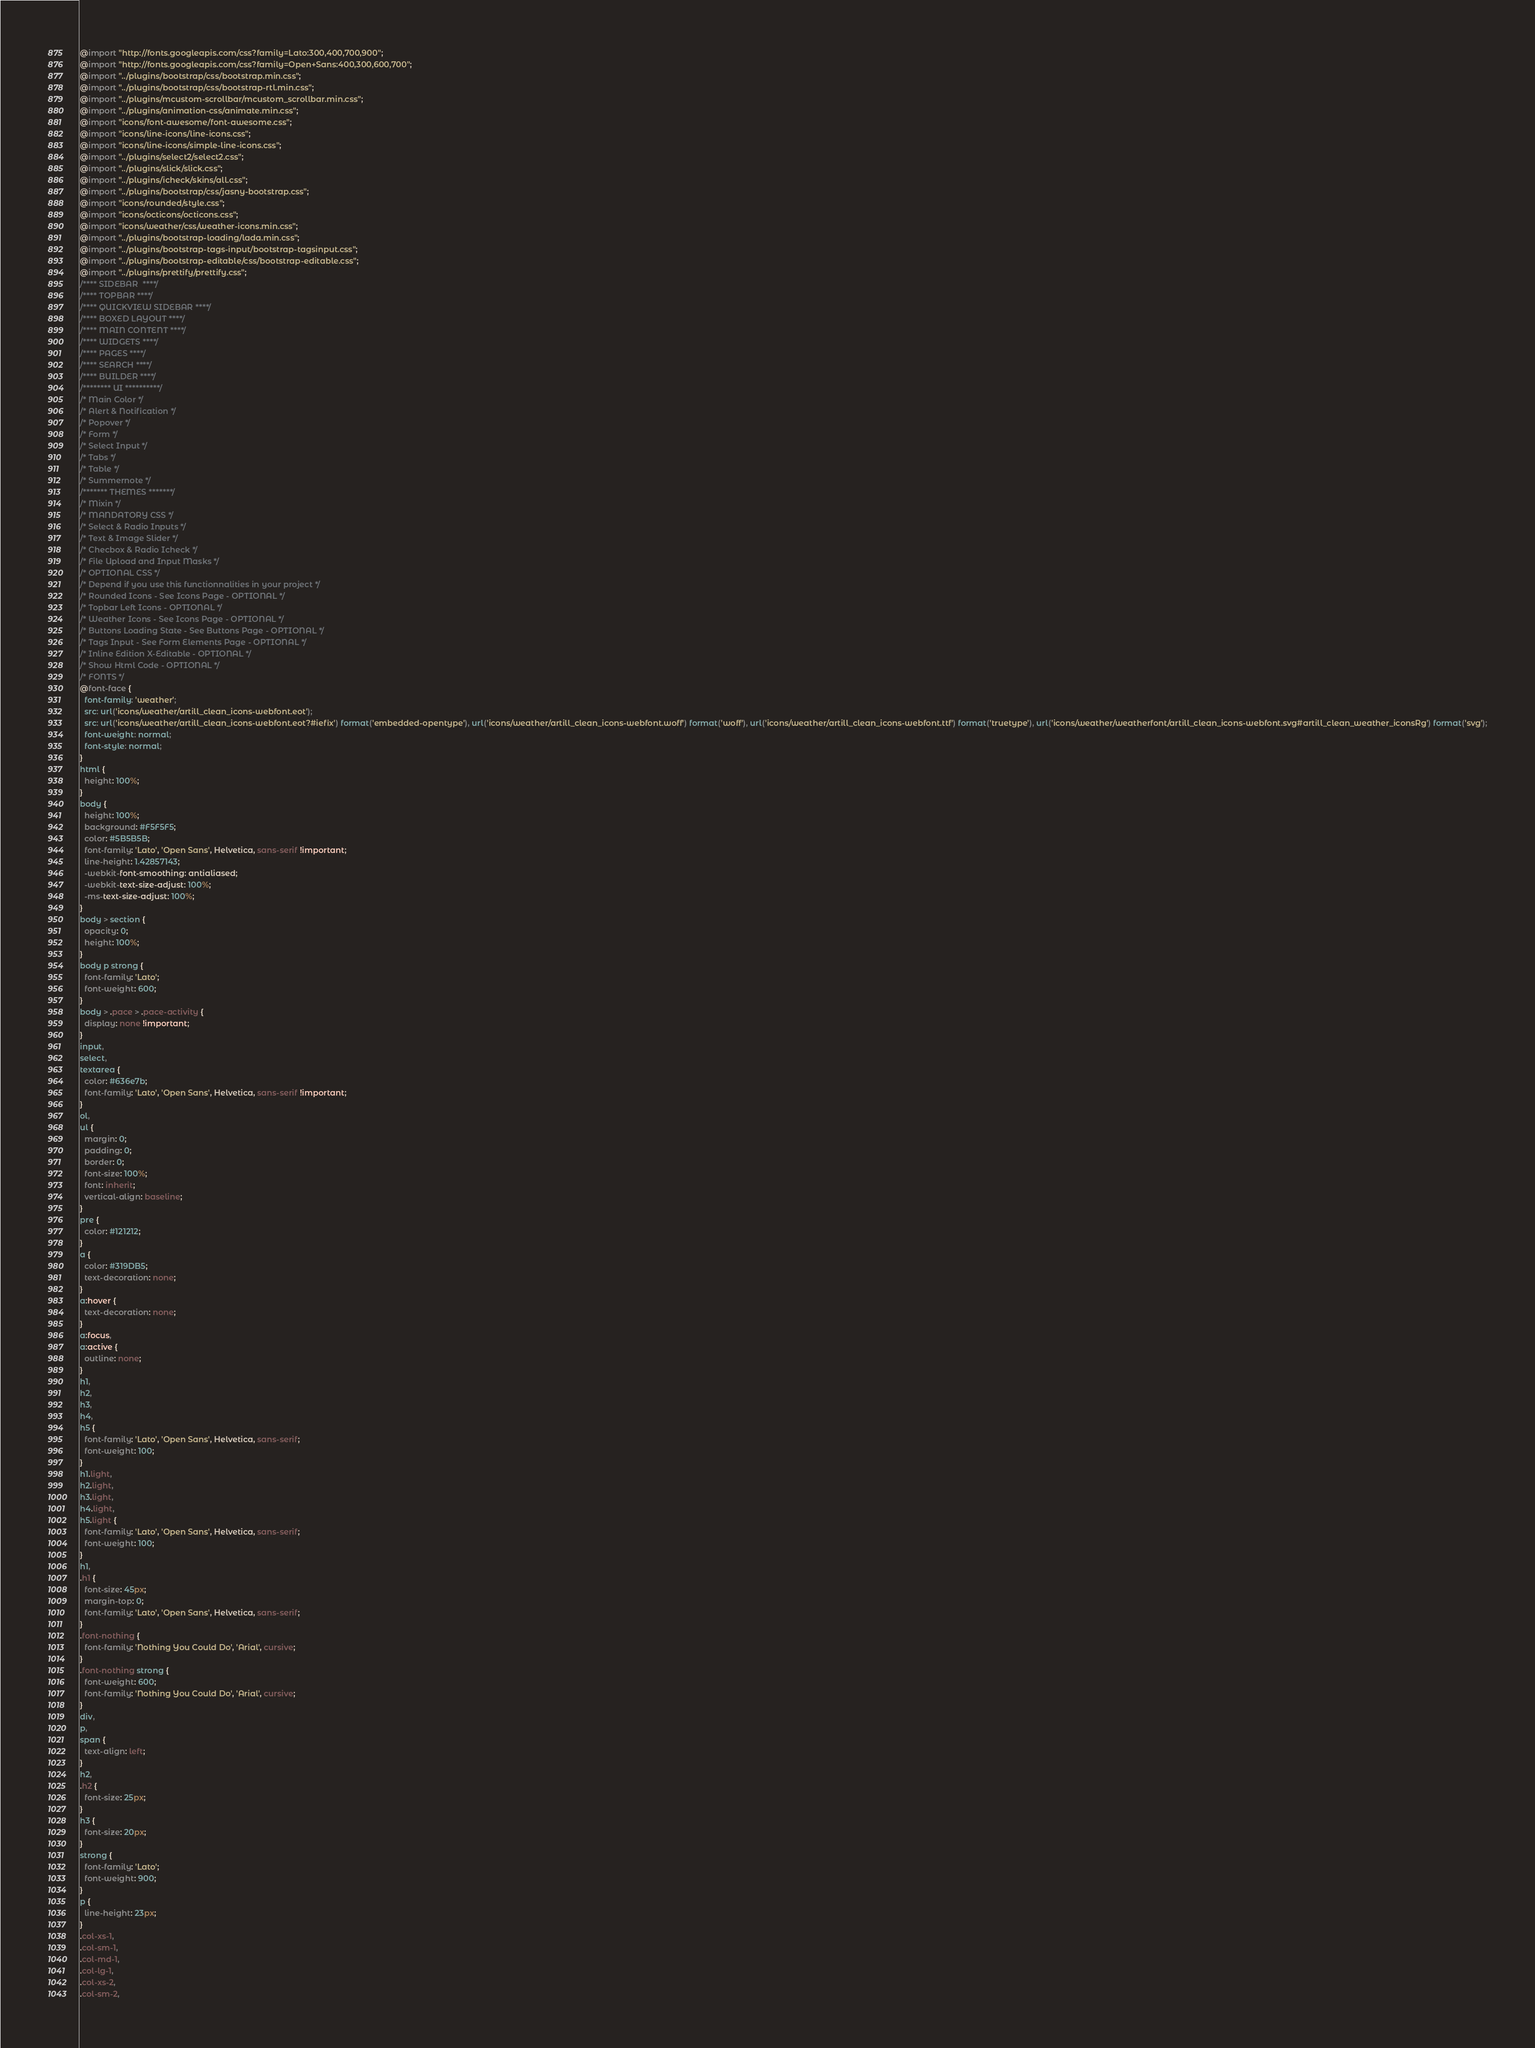Convert code to text. <code><loc_0><loc_0><loc_500><loc_500><_CSS_>@import "http://fonts.googleapis.com/css?family=Lato:300,400,700,900";
@import "http://fonts.googleapis.com/css?family=Open+Sans:400,300,600,700";
@import "../plugins/bootstrap/css/bootstrap.min.css";
@import "../plugins/bootstrap/css/bootstrap-rtl.min.css";
@import "../plugins/mcustom-scrollbar/mcustom_scrollbar.min.css";
@import "../plugins/animation-css/animate.min.css";
@import "icons/font-awesome/font-awesome.css";
@import "icons/line-icons/line-icons.css";
@import "icons/line-icons/simple-line-icons.css";
@import "../plugins/select2/select2.css";
@import "../plugins/slick/slick.css";
@import "../plugins/icheck/skins/all.css";
@import "../plugins/bootstrap/css/jasny-bootstrap.css";
@import "icons/rounded/style.css";
@import "icons/octicons/octicons.css";
@import "icons/weather/css/weather-icons.min.css";
@import "../plugins/bootstrap-loading/lada.min.css";
@import "../plugins/bootstrap-tags-input/bootstrap-tagsinput.css";
@import "../plugins/bootstrap-editable/css/bootstrap-editable.css";
@import "../plugins/prettify/prettify.css";
/**** SIDEBAR  ****/
/**** TOPBAR ****/
/**** QUICKVIEW SIDEBAR ****/
/**** BOXED LAYOUT ****/
/**** MAIN CONTENT ****/
/**** WIDGETS ****/
/**** PAGES ****/
/**** SEARCH ****/
/**** BUILDER ****/
/******** UI **********/
/* Main Color */
/* Alert & Notification */
/* Popover */
/* Form */
/* Select Input */
/* Tabs */
/* Table */
/* Summernote */
/******* THEMES *******/
/* Mixin */
/* MANDATORY CSS */
/* Select & Radio Inputs */
/* Text & Image Slider */
/* Checbox & Radio Icheck */
/* File Upload and Input Masks */
/* OPTIONAL CSS */
/* Depend if you use this functionnalities in your project */
/* Rounded Icons - See Icons Page - OPTIONAL */
/* Topbar Left Icons - OPTIONAL */
/* Weather Icons - See Icons Page - OPTIONAL */
/* Buttons Loading State - See Buttons Page - OPTIONAL */
/* Tags Input - See Form Elements Page - OPTIONAL */
/* Inline Edition X-Editable - OPTIONAL */
/* Show Html Code - OPTIONAL */
/* FONTS */
@font-face {
  font-family: 'weather';
  src: url('icons/weather/artill_clean_icons-webfont.eot');
  src: url('icons/weather/artill_clean_icons-webfont.eot?#iefix') format('embedded-opentype'), url('icons/weather/artill_clean_icons-webfont.woff') format('woff'), url('icons/weather/artill_clean_icons-webfont.ttf') format('truetype'), url('icons/weather/weatherfont/artill_clean_icons-webfont.svg#artill_clean_weather_iconsRg') format('svg');
  font-weight: normal;
  font-style: normal;
}
html {
  height: 100%;
}
body {
  height: 100%;
  background: #F5F5F5;
  color: #5B5B5B;
  font-family: 'Lato', 'Open Sans', Helvetica, sans-serif !important;
  line-height: 1.42857143;
  -webkit-font-smoothing: antialiased;
  -webkit-text-size-adjust: 100%;
  -ms-text-size-adjust: 100%;
}
body > section {
  opacity: 0;
  height: 100%;
}
body p strong {
  font-family: 'Lato';
  font-weight: 600;
}
body > .pace > .pace-activity {
  display: none !important;
}
input,
select,
textarea {
  color: #636e7b;
  font-family: 'Lato', 'Open Sans', Helvetica, sans-serif !important;
}
ol,
ul {
  margin: 0;
  padding: 0;
  border: 0;
  font-size: 100%;
  font: inherit;
  vertical-align: baseline;
}
pre {
  color: #121212;
}
a {
  color: #319DB5;
  text-decoration: none;
}
a:hover {
  text-decoration: none;
}
a:focus,
a:active {
  outline: none;
}
h1,
h2,
h3,
h4,
h5 {
  font-family: 'Lato', 'Open Sans', Helvetica, sans-serif;
  font-weight: 100;
}
h1.light,
h2.light,
h3.light,
h4.light,
h5.light {
  font-family: 'Lato', 'Open Sans', Helvetica, sans-serif;
  font-weight: 100;
}
h1,
.h1 {
  font-size: 45px;
  margin-top: 0;
  font-family: 'Lato', 'Open Sans', Helvetica, sans-serif;
}
.font-nothing {
  font-family: 'Nothing You Could Do', 'Arial', cursive;
}
.font-nothing strong {
  font-weight: 600;
  font-family: 'Nothing You Could Do', 'Arial', cursive;
}
div,
p,
span {
  text-align: left;
}
h2,
.h2 {
  font-size: 25px;
}
h3 {
  font-size: 20px;
}
strong {
  font-family: 'Lato';
  font-weight: 900;
}
p {
  line-height: 23px;
}
.col-xs-1,
.col-sm-1,
.col-md-1,
.col-lg-1,
.col-xs-2,
.col-sm-2,</code> 